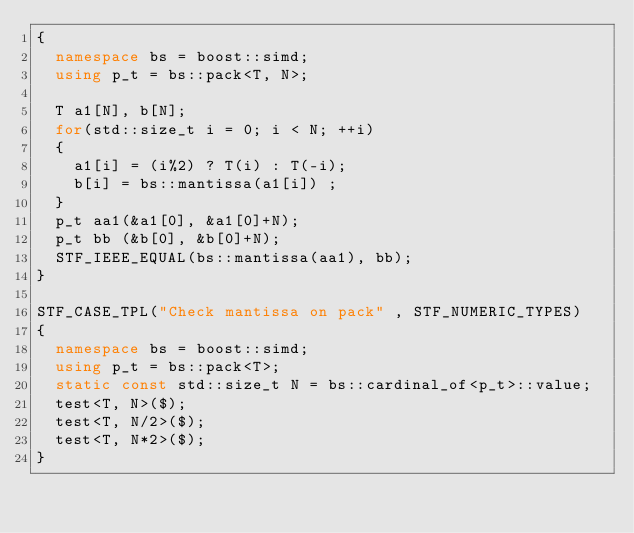<code> <loc_0><loc_0><loc_500><loc_500><_C++_>{
  namespace bs = boost::simd;
  using p_t = bs::pack<T, N>;

  T a1[N], b[N];
  for(std::size_t i = 0; i < N; ++i)
  {
    a1[i] = (i%2) ? T(i) : T(-i);
    b[i] = bs::mantissa(a1[i]) ;
  }
  p_t aa1(&a1[0], &a1[0]+N);
  p_t bb (&b[0], &b[0]+N);
  STF_IEEE_EQUAL(bs::mantissa(aa1), bb);
}

STF_CASE_TPL("Check mantissa on pack" , STF_NUMERIC_TYPES)
{
  namespace bs = boost::simd;
  using p_t = bs::pack<T>;
  static const std::size_t N = bs::cardinal_of<p_t>::value;
  test<T, N>($);
  test<T, N/2>($);
  test<T, N*2>($);
}
</code> 